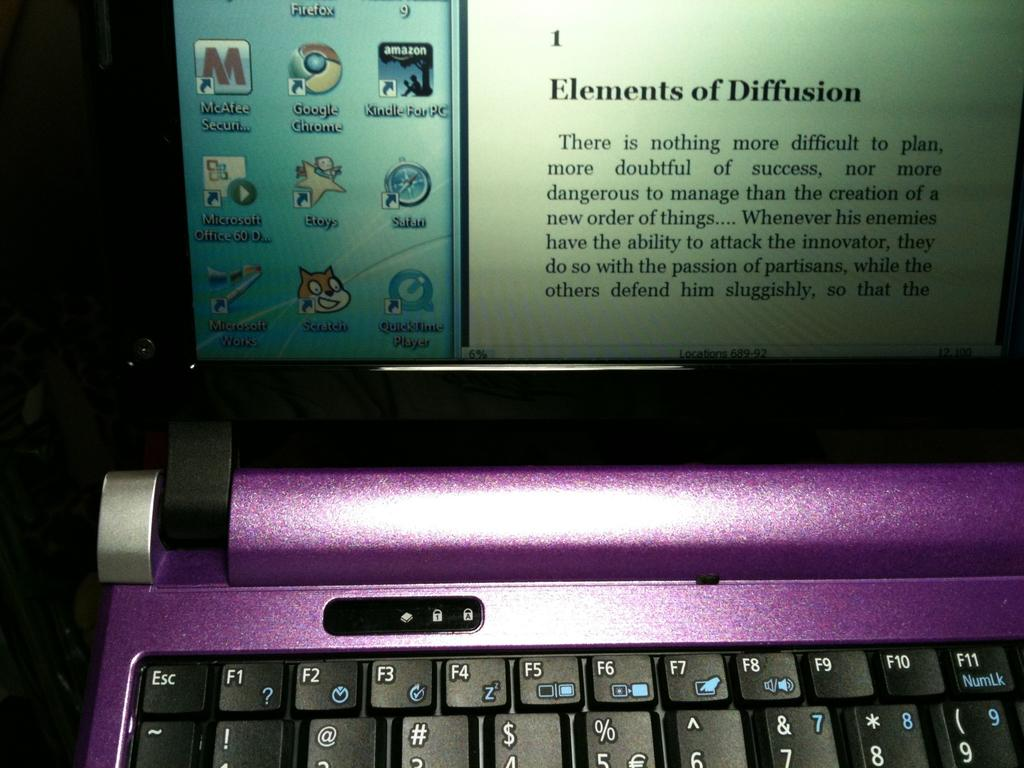<image>
Write a terse but informative summary of the picture. A laptop screen displays the many apps installed including Google Chrome, Safari and Quicktime Player. 